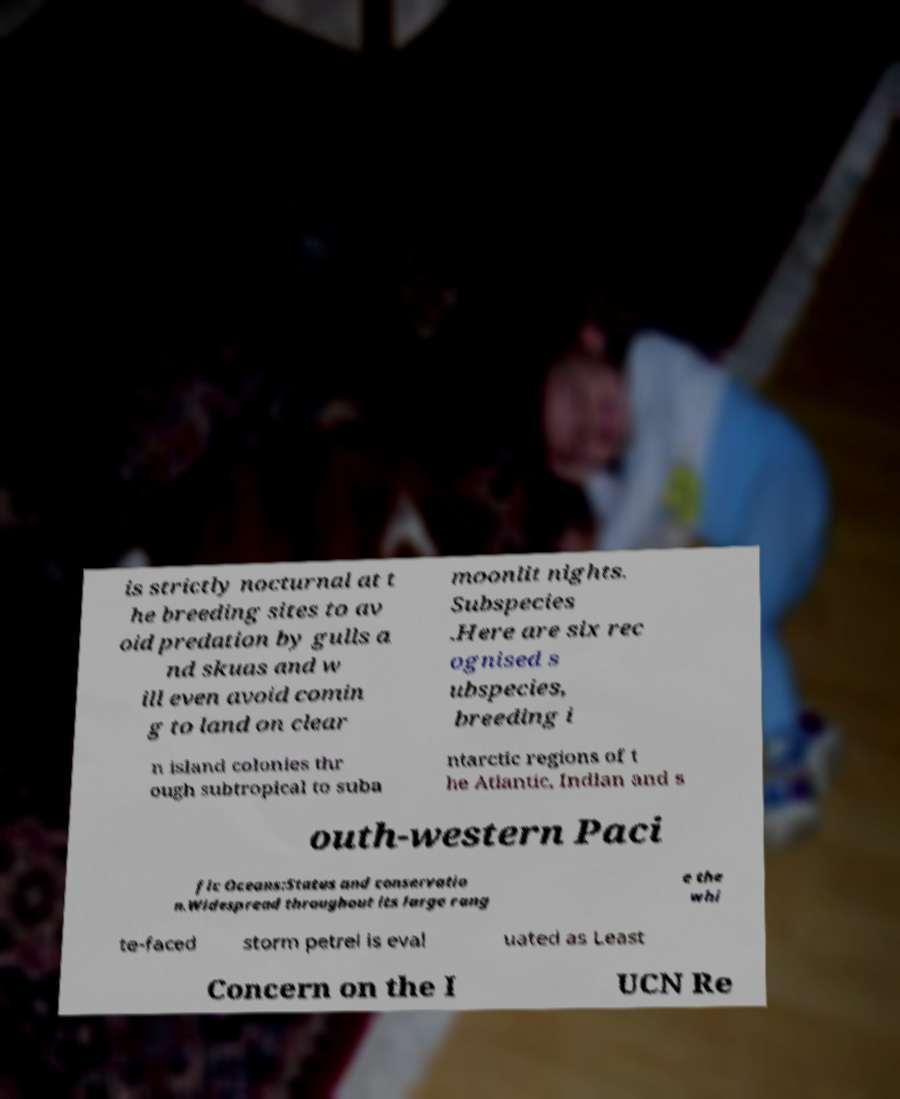Please identify and transcribe the text found in this image. is strictly nocturnal at t he breeding sites to av oid predation by gulls a nd skuas and w ill even avoid comin g to land on clear moonlit nights. Subspecies .Here are six rec ognised s ubspecies, breeding i n island colonies thr ough subtropical to suba ntarctic regions of t he Atlantic, Indian and s outh-western Paci fic Oceans:Status and conservatio n.Widespread throughout its large rang e the whi te-faced storm petrel is eval uated as Least Concern on the I UCN Re 